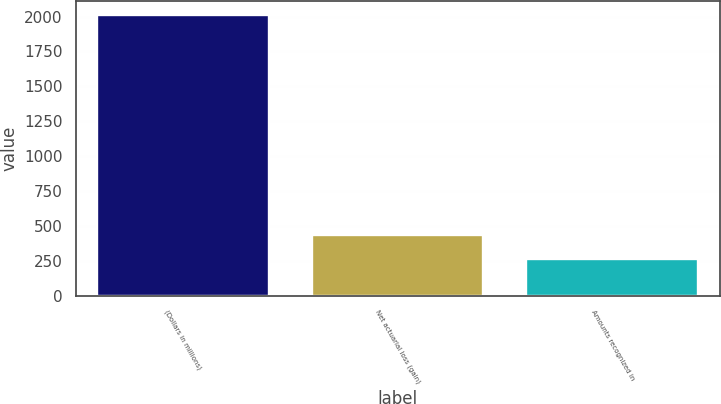Convert chart. <chart><loc_0><loc_0><loc_500><loc_500><bar_chart><fcel>(Dollars in millions)<fcel>Net actuarial loss (gain)<fcel>Amounts recognized in<nl><fcel>2013<fcel>437.1<fcel>262<nl></chart> 